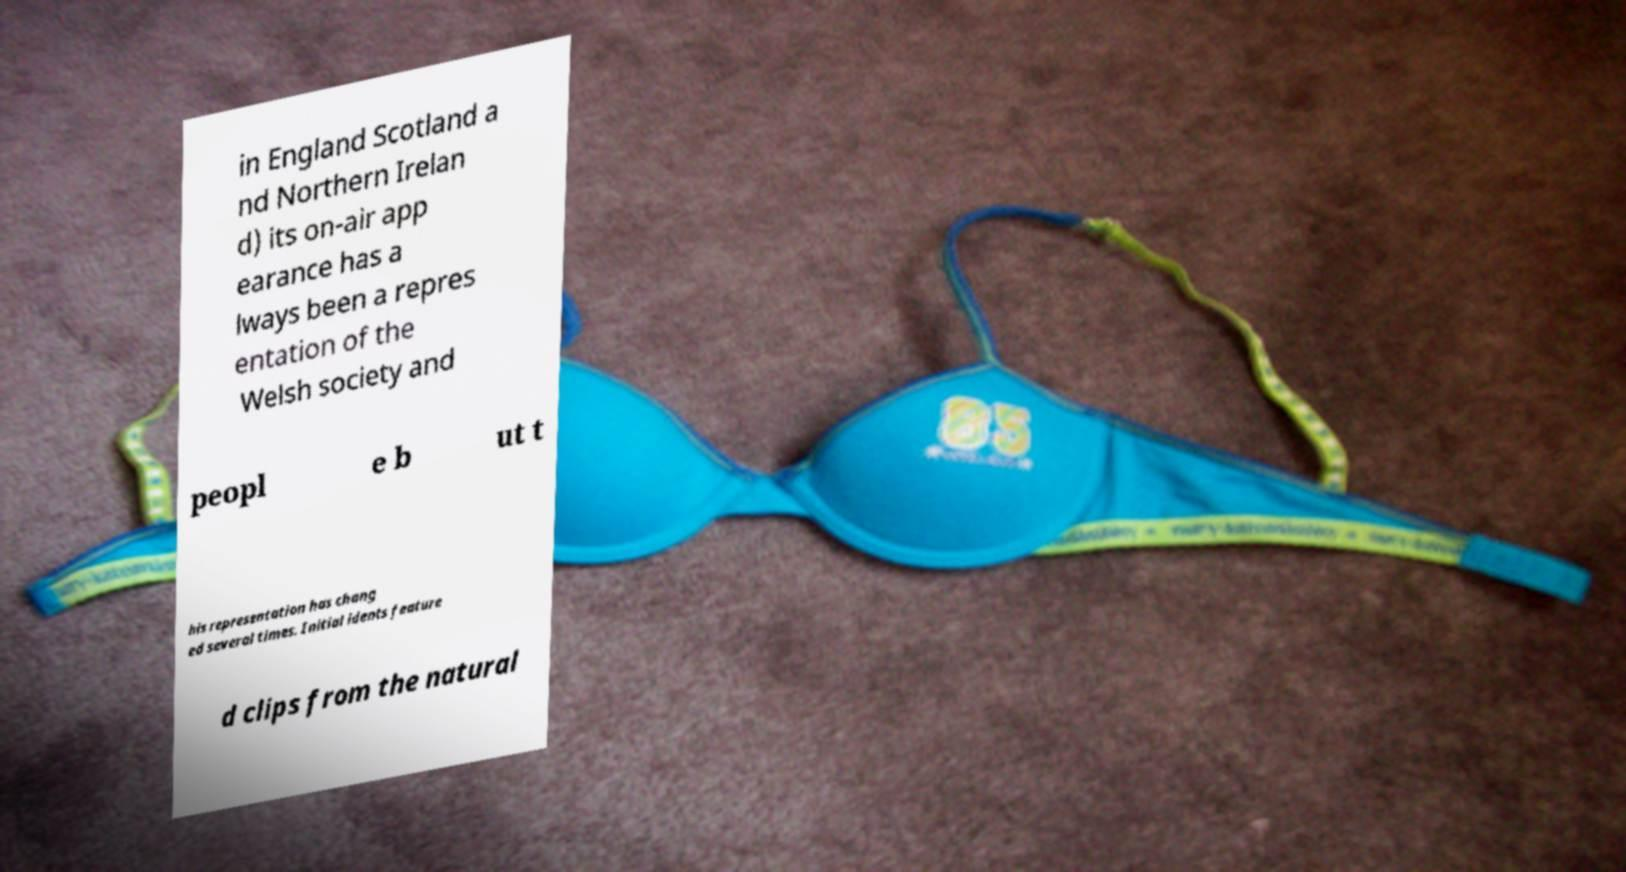Could you assist in decoding the text presented in this image and type it out clearly? in England Scotland a nd Northern Irelan d) its on-air app earance has a lways been a repres entation of the Welsh society and peopl e b ut t his representation has chang ed several times. Initial idents feature d clips from the natural 